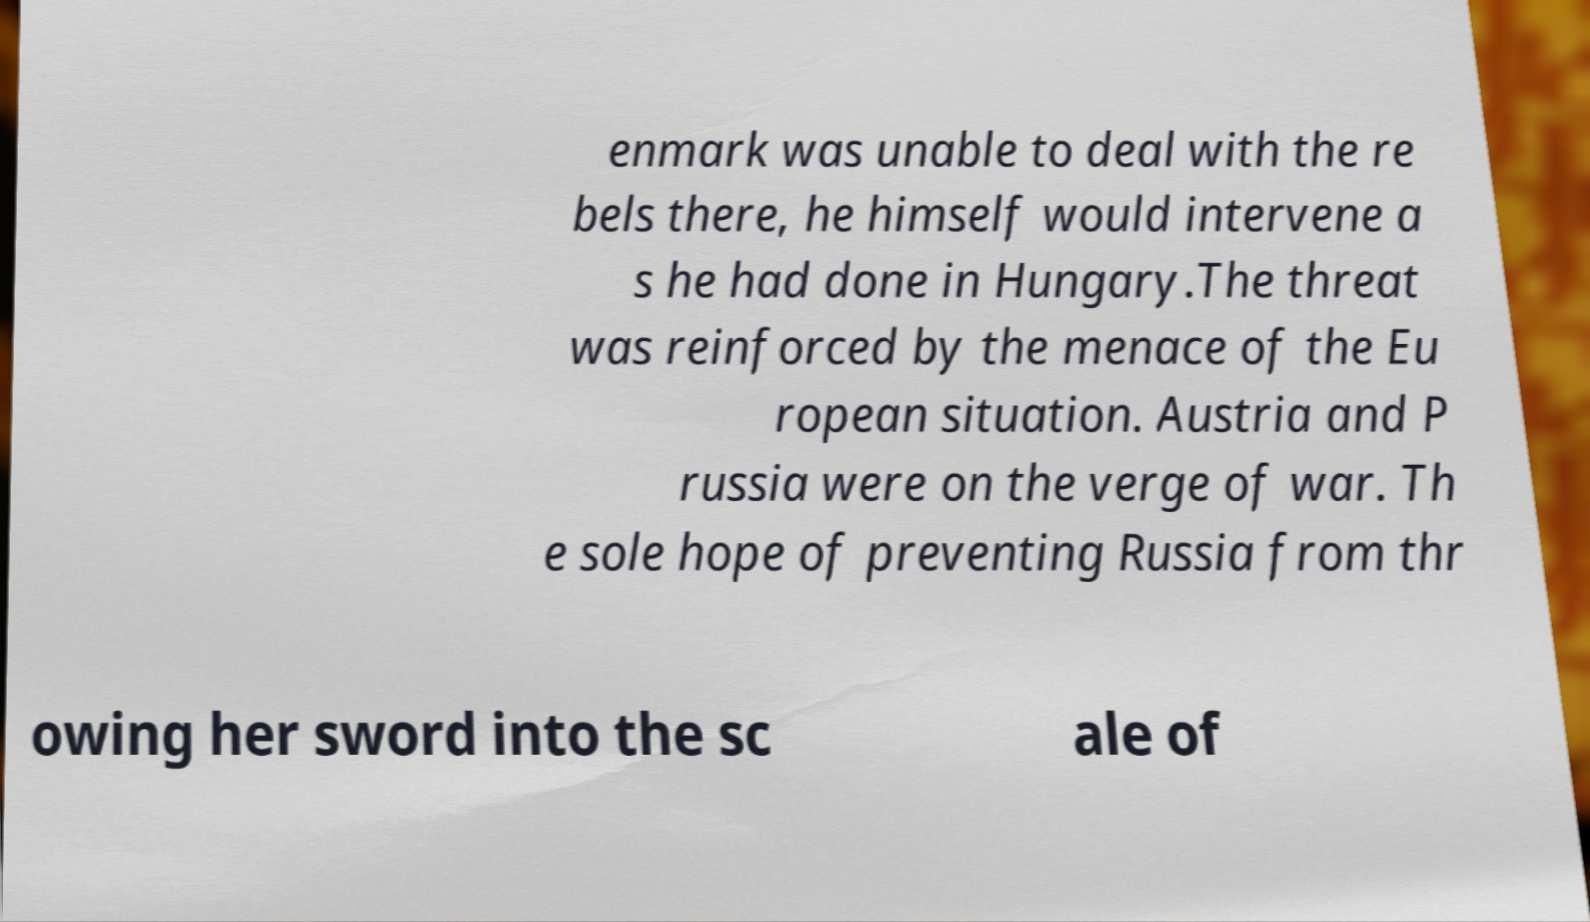There's text embedded in this image that I need extracted. Can you transcribe it verbatim? enmark was unable to deal with the re bels there, he himself would intervene a s he had done in Hungary.The threat was reinforced by the menace of the Eu ropean situation. Austria and P russia were on the verge of war. Th e sole hope of preventing Russia from thr owing her sword into the sc ale of 